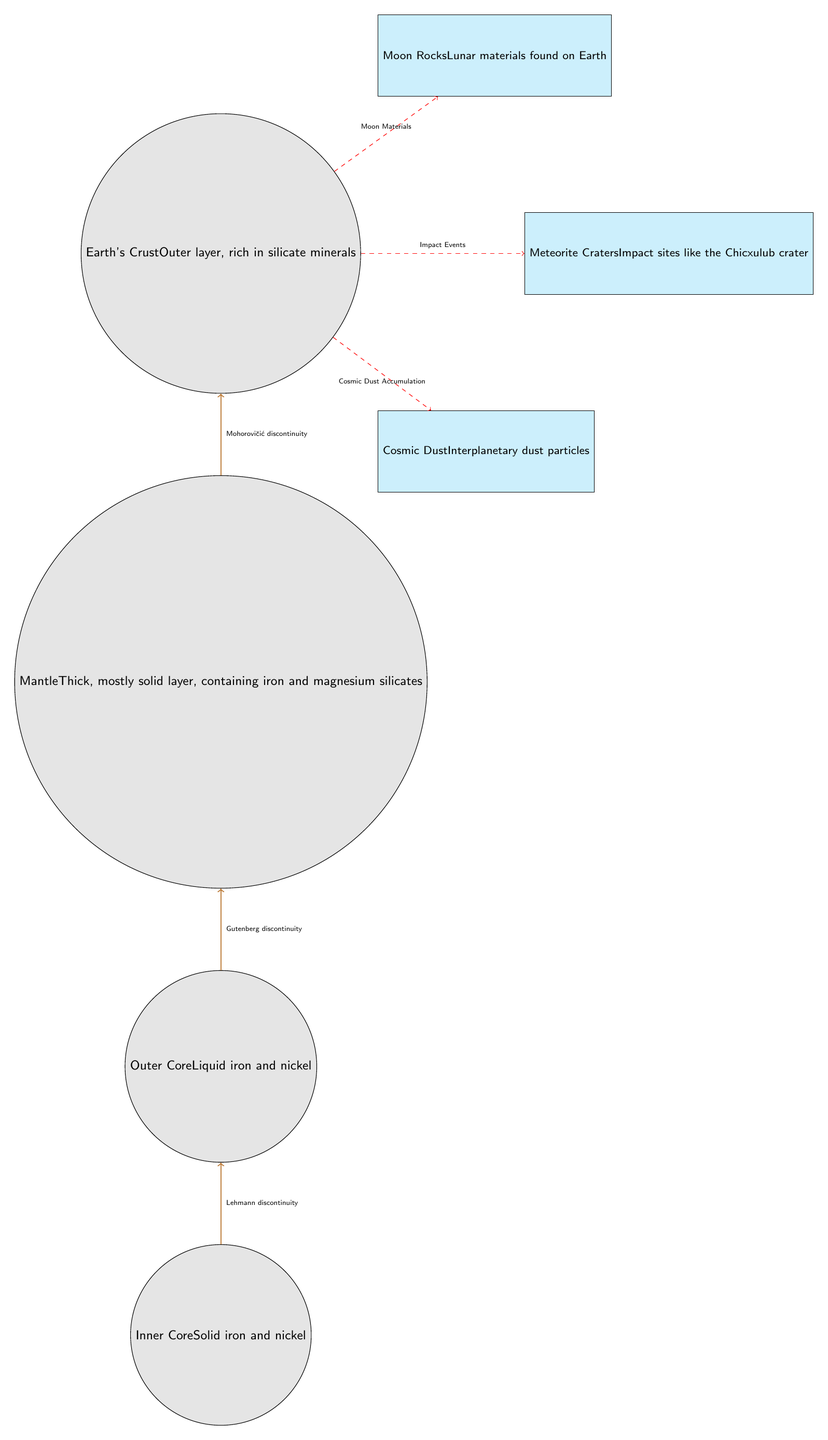What are the four main layers of Earth shown in the diagram? The diagram lists four main layers: Inner Core, Outer Core, Mantle, and Earth's Crust.
Answer: Inner Core, Outer Core, Mantle, Earth's Crust What is the composition of the Inner Core? The Inner Core is described in the diagram as being composed of solid iron and nickel.
Answer: Solid iron and nickel What type of materials are found in Moon Rocks? The diagram labels Moon Rocks as lunar materials found on Earth, indicating their origin.
Answer: Lunar materials How many boundaries are indicated between the layers? The diagram shows three boundaries: Lehmann discontinuity, Gutenberg discontinuity, and Mohorovičić discontinuity, hence the total is 3.
Answer: 3 What celestial influence is represented as "Cosmic Dust"? The diagram identifies "Cosmic Dust" as interplanetary dust particles that accumulate in Earth's crust.
Answer: Interplanetary dust particles Explain the relationship between the Earth's Crust and Meteorite Craters. The diagram shows an influence with a dashed arrow labeled "Impact Events" from Earth's Crust to Meteorite Craters, indicating that craters are a result of impacts on the crust.
Answer: Impact Events What happens at the Gutenberg discontinuity? The Gutenberg discontinuity, depicted in the diagram, marks the transition between the liquid Outer Core and the solid Mantle.
Answer: Transition between Outer Core and Mantle Which extraterrestrial influence is directly associated with the Earth's Crust? The diagram shows influences on Earth's Crust from Meteorite Craters, Moon Rocks, and Cosmic Dust. Each influence indicates a direct connection to the crust.
Answer: Meteorite Craters, Moon Rocks, Cosmic Dust What is the significance of the Chicxulub crater as shown in the diagram? The diagram points out the Chicxulub crater as an example of a meteorite impact site, suggesting its historical significance related to Earth's geological history.
Answer: Meteorite Impact Site 